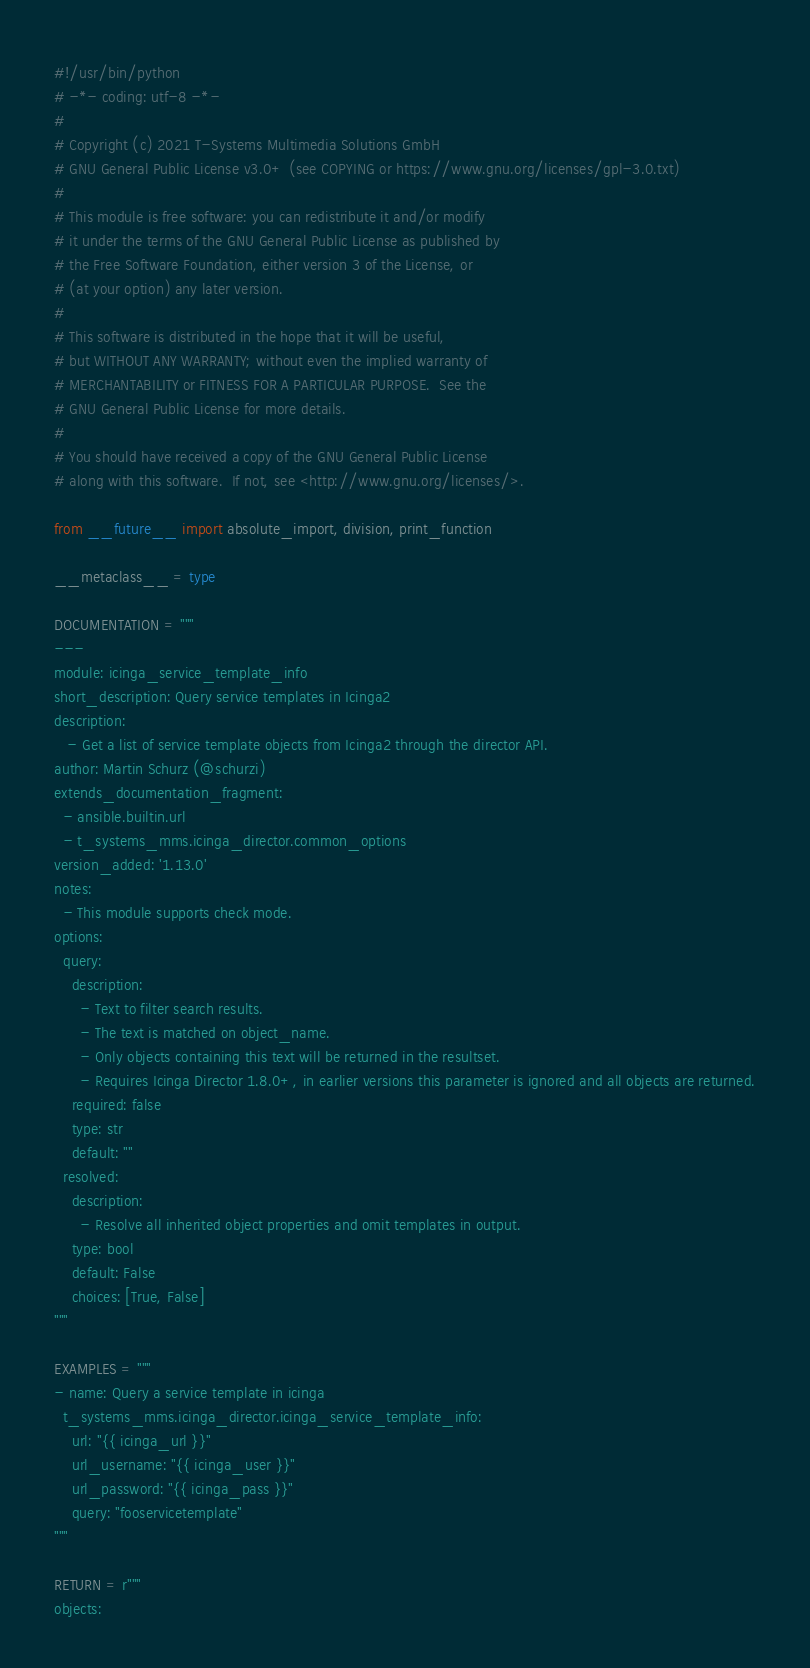Convert code to text. <code><loc_0><loc_0><loc_500><loc_500><_Python_>#!/usr/bin/python
# -*- coding: utf-8 -*-
#
# Copyright (c) 2021 T-Systems Multimedia Solutions GmbH
# GNU General Public License v3.0+ (see COPYING or https://www.gnu.org/licenses/gpl-3.0.txt)
#
# This module is free software: you can redistribute it and/or modify
# it under the terms of the GNU General Public License as published by
# the Free Software Foundation, either version 3 of the License, or
# (at your option) any later version.
#
# This software is distributed in the hope that it will be useful,
# but WITHOUT ANY WARRANTY; without even the implied warranty of
# MERCHANTABILITY or FITNESS FOR A PARTICULAR PURPOSE.  See the
# GNU General Public License for more details.
#
# You should have received a copy of the GNU General Public License
# along with this software.  If not, see <http://www.gnu.org/licenses/>.

from __future__ import absolute_import, division, print_function

__metaclass__ = type

DOCUMENTATION = """
---
module: icinga_service_template_info
short_description: Query service templates in Icinga2
description:
   - Get a list of service template objects from Icinga2 through the director API.
author: Martin Schurz (@schurzi)
extends_documentation_fragment:
  - ansible.builtin.url
  - t_systems_mms.icinga_director.common_options
version_added: '1.13.0'
notes:
  - This module supports check mode.
options:
  query:
    description:
      - Text to filter search results.
      - The text is matched on object_name.
      - Only objects containing this text will be returned in the resultset.
      - Requires Icinga Director 1.8.0+, in earlier versions this parameter is ignored and all objects are returned.
    required: false
    type: str
    default: ""
  resolved:
    description:
      - Resolve all inherited object properties and omit templates in output.
    type: bool
    default: False
    choices: [True, False]
"""

EXAMPLES = """
- name: Query a service template in icinga
  t_systems_mms.icinga_director.icinga_service_template_info:
    url: "{{ icinga_url }}"
    url_username: "{{ icinga_user }}"
    url_password: "{{ icinga_pass }}"
    query: "fooservicetemplate"
"""

RETURN = r"""
objects:</code> 